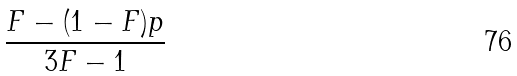<formula> <loc_0><loc_0><loc_500><loc_500>\frac { F - ( 1 - F ) p } { 3 F - 1 }</formula> 